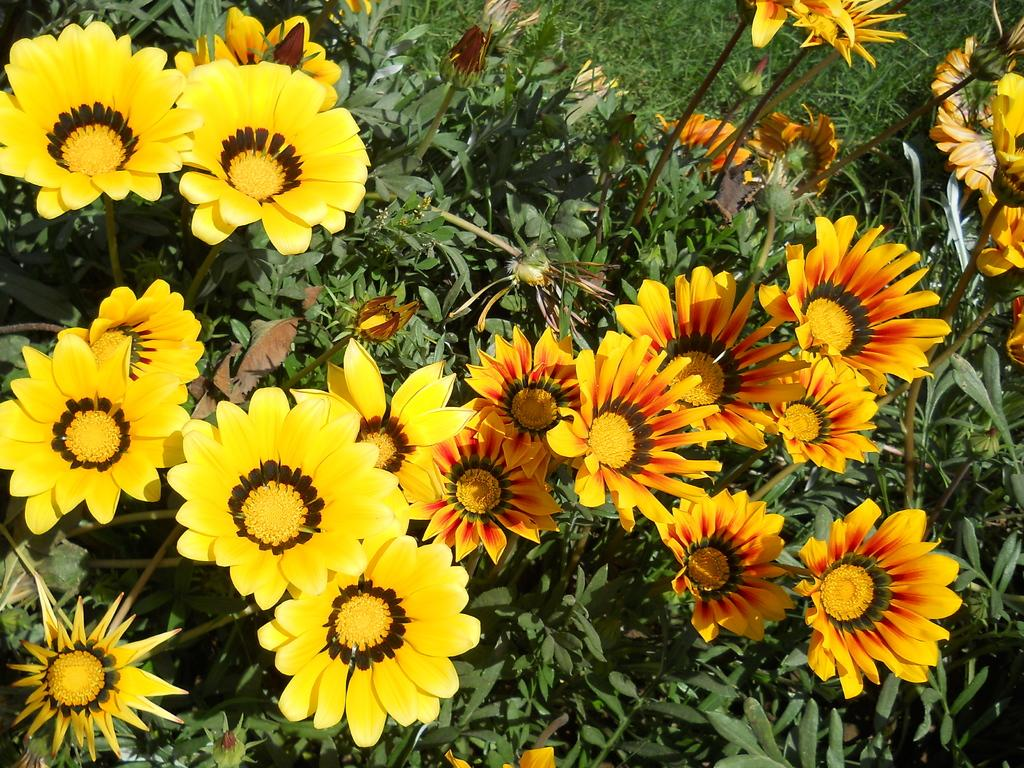What type of vegetation can be seen in the image? There are many plants, flowers, and leaves present in the image. Are there any unopened parts of the plants visible? Yes, buds are visible in the image. What type of ground vegetation is present at the top of the image? There is grass at the top of the image. What type of horn can be seen in the image? There is no horn present in the image. Is there any smoke visible in the image? No, there is no smoke visible in the image. 